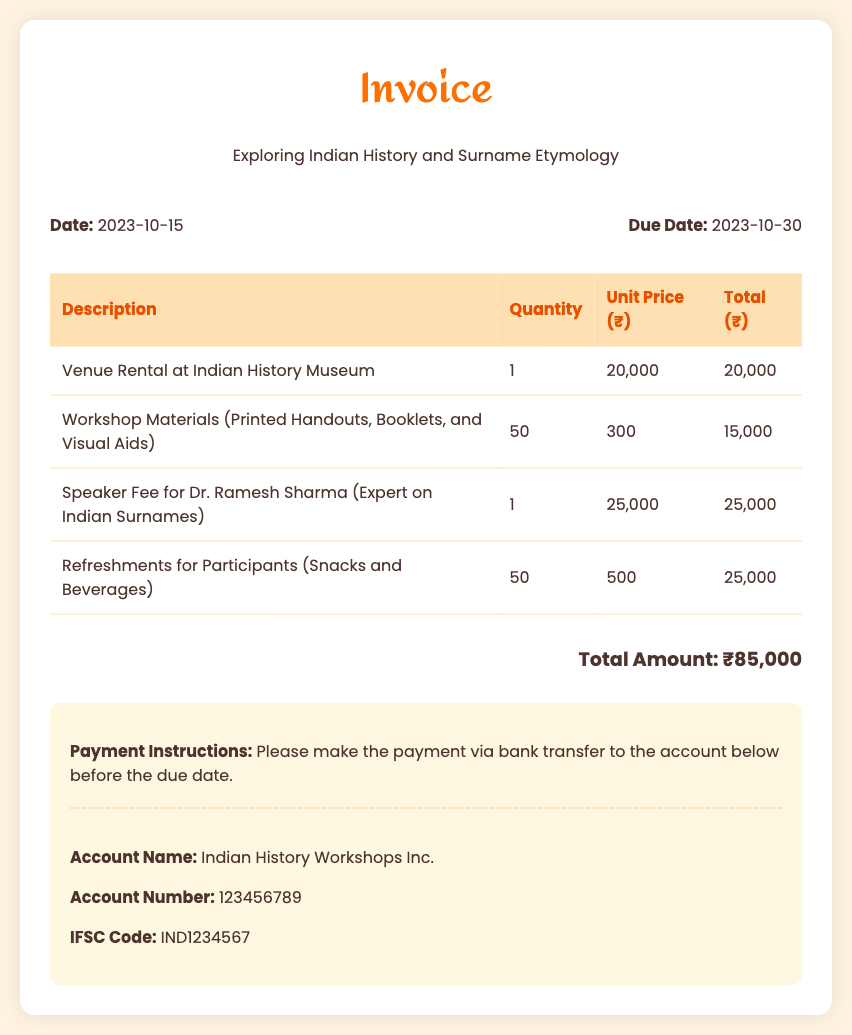What is the total amount due? The total amount is the sum of all costs listed in the invoice, which is ₹85,000.
Answer: ₹85,000 Who is the speaker for the workshop? The speaker's name is mentioned in the invoice as Dr. Ramesh Sharma, who specializes in Indian surnames.
Answer: Dr. Ramesh Sharma What is the date of the invoice? The invoice date is specified at the top of the document as 2023-10-15.
Answer: 2023-10-15 How much is the unit price for workshop materials? The unit price for workshop materials is listed in the invoice as ₹300.
Answer: ₹300 What is the quantity of refreshments for participants? The quantity of refreshments provided for participants is indicated as 50.
Answer: 50 What venue was rented for the workshop? The venue mentioned in the invoice for the rental is the Indian History Museum.
Answer: Indian History Museum What is the due date for the payment? The due date for payment is clearly stated in the invoice as 2023-10-30.
Answer: 2023-10-30 What type of document is this? The document is an invoice for a workshop on Indian history and surname etymology.
Answer: Invoice 